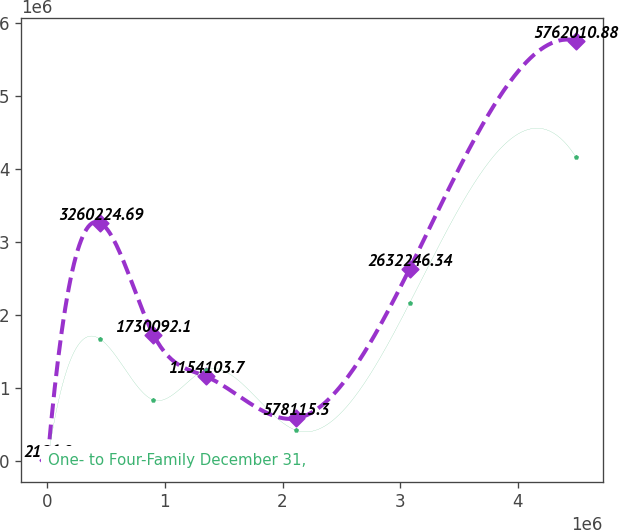<chart> <loc_0><loc_0><loc_500><loc_500><line_chart><ecel><fcel>Home Equity December 31,<fcel>One- to Four-Family December 31,<nl><fcel>1951.19<fcel>2126.9<fcel>1724.93<nl><fcel>451575<fcel>3.26022e+06<fcel>1.66497e+06<nl><fcel>901199<fcel>1.73009e+06<fcel>833347<nl><fcel>1.35082e+06<fcel>1.1541e+06<fcel>1.24916e+06<nl><fcel>2.11278e+06<fcel>578115<fcel>417536<nl><fcel>3.08092e+06<fcel>2.63225e+06<fcel>2.16137e+06<nl><fcel>4.49819e+06<fcel>5.76201e+06<fcel>4.15984e+06<nl></chart> 